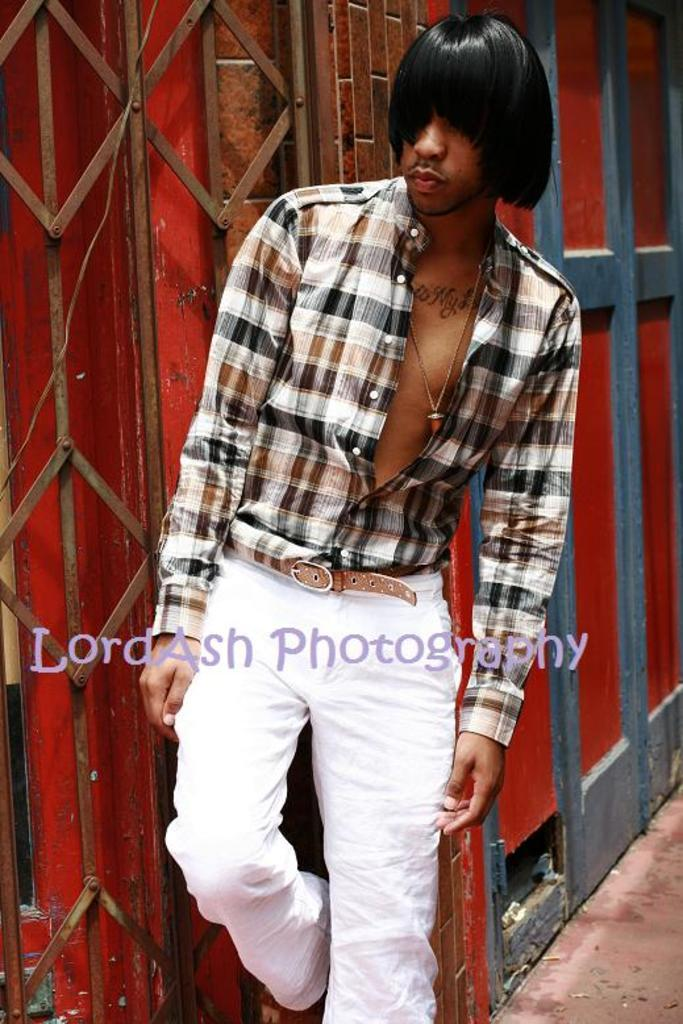What is the main subject of the image? The main subject of the image is a man. What is the man wearing in the image? The man is wearing a shirt, trousers, and shoes in the image. Where is the man standing in the image? The man is standing near a steel gate in the image. What can be seen in the background of the image? There is a red color wall in the image. Is there any additional information about the image itself? Yes, there is a watermark in the image. Can you tell me how many bottles of soda the man is holding in the image? There is no mention of soda or bottles in the image; the man is not holding any soda. What type of ghost is visible in the image? There is no ghost present in the image; it features a man standing near a steel gate. 